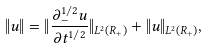<formula> <loc_0><loc_0><loc_500><loc_500>\| u \| = \| \frac { \partial _ { - } ^ { 1 / 2 } u } { \partial t ^ { 1 / 2 } } \| _ { L ^ { 2 } ( { R } _ { + } ) } + \| u \| _ { L ^ { 2 } ( { R } _ { + } ) } ,</formula> 